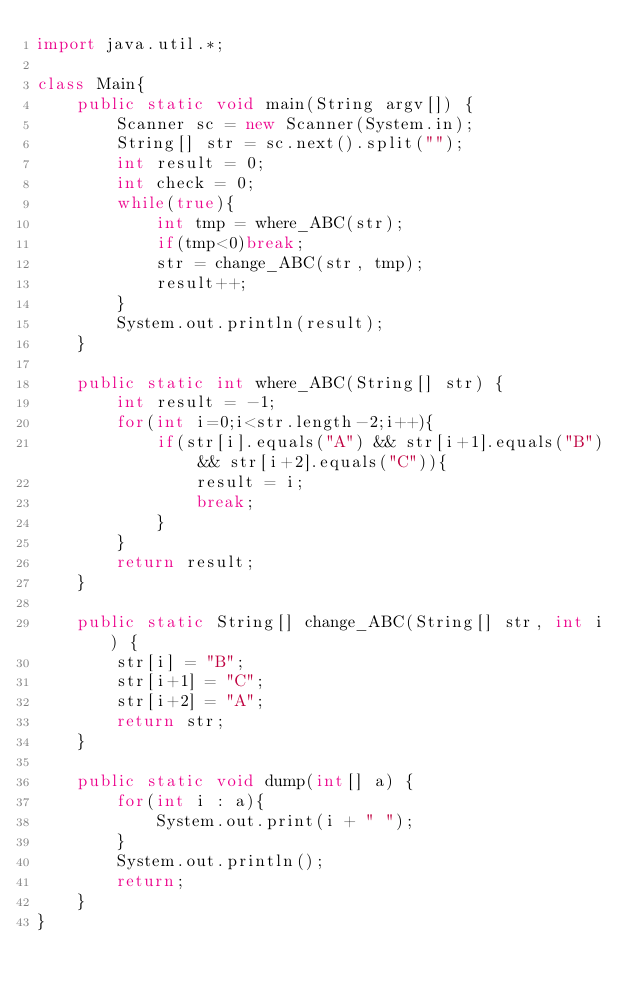<code> <loc_0><loc_0><loc_500><loc_500><_Java_>import java.util.*;

class Main{
    public static void main(String argv[]) {
        Scanner sc = new Scanner(System.in);
        String[] str = sc.next().split("");
        int result = 0;
        int check = 0;
        while(true){
            int tmp = where_ABC(str);
            if(tmp<0)break;
            str = change_ABC(str, tmp);
            result++;
        }
        System.out.println(result);
    }

    public static int where_ABC(String[] str) {
        int result = -1;
        for(int i=0;i<str.length-2;i++){
            if(str[i].equals("A") && str[i+1].equals("B") && str[i+2].equals("C")){
                result = i;
                break;
            }
        }
        return result;
    }

    public static String[] change_ABC(String[] str, int i) {
        str[i] = "B";
        str[i+1] = "C";
        str[i+2] = "A";
        return str;
    }

    public static void dump(int[] a) {
        for(int i : a){
            System.out.print(i + " ");
        }
        System.out.println();
        return;
    }
}</code> 